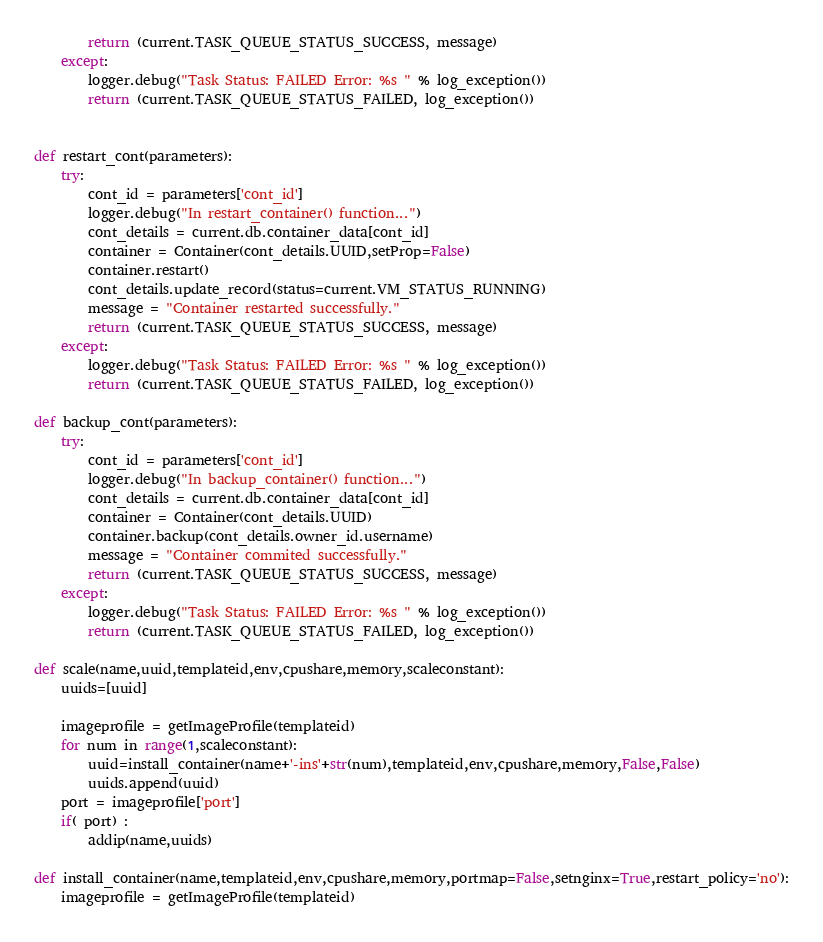Convert code to text. <code><loc_0><loc_0><loc_500><loc_500><_Python_>        return (current.TASK_QUEUE_STATUS_SUCCESS, message)                    
    except:
        logger.debug("Task Status: FAILED Error: %s " % log_exception())
        return (current.TASK_QUEUE_STATUS_FAILED, log_exception())


def restart_cont(parameters):
    try:
        cont_id = parameters['cont_id']
        logger.debug("In restart_container() function...")
        cont_details = current.db.container_data[cont_id]
        container = Container(cont_details.UUID,setProp=False)
        container.restart()
        cont_details.update_record(status=current.VM_STATUS_RUNNING)
        message = "Container restarted successfully."
        return (current.TASK_QUEUE_STATUS_SUCCESS, message)                    
    except:
        logger.debug("Task Status: FAILED Error: %s " % log_exception())
        return (current.TASK_QUEUE_STATUS_FAILED, log_exception())

def backup_cont(parameters):
    try:
        cont_id = parameters['cont_id']
        logger.debug("In backup_container() function...")
        cont_details = current.db.container_data[cont_id]
        container = Container(cont_details.UUID)
        container.backup(cont_details.owner_id.username)
        message = "Container commited successfully."
        return (current.TASK_QUEUE_STATUS_SUCCESS, message)                    
    except:
        logger.debug("Task Status: FAILED Error: %s " % log_exception())
        return (current.TASK_QUEUE_STATUS_FAILED, log_exception())

def scale(name,uuid,templateid,env,cpushare,memory,scaleconstant):
    uuids=[uuid]
    
    imageprofile = getImageProfile(templateid)
    for num in range(1,scaleconstant):
        uuid=install_container(name+'-ins'+str(num),templateid,env,cpushare,memory,False,False)
        uuids.append(uuid)
    port = imageprofile['port']
    if( port) :    
        addip(name,uuids)

def install_container(name,templateid,env,cpushare,memory,portmap=False,setnginx=True,restart_policy='no'):
    imageprofile = getImageProfile(templateid)</code> 